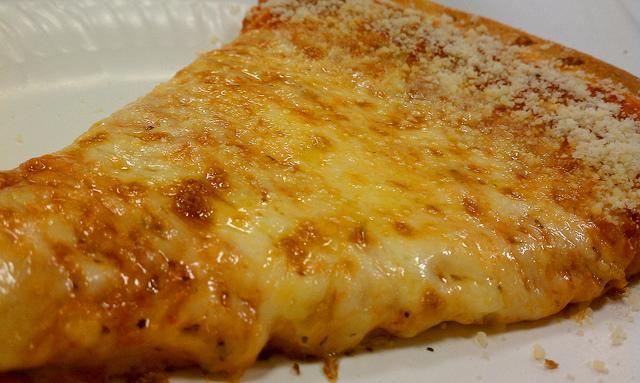What is the pizza on?
Give a very brief answer. Plate. What kind of bread is this?
Be succinct. Pizza. What shape is the pizza slice?
Be succinct. Triangle. What is the melted orange stuff called?
Give a very brief answer. Cheese. 